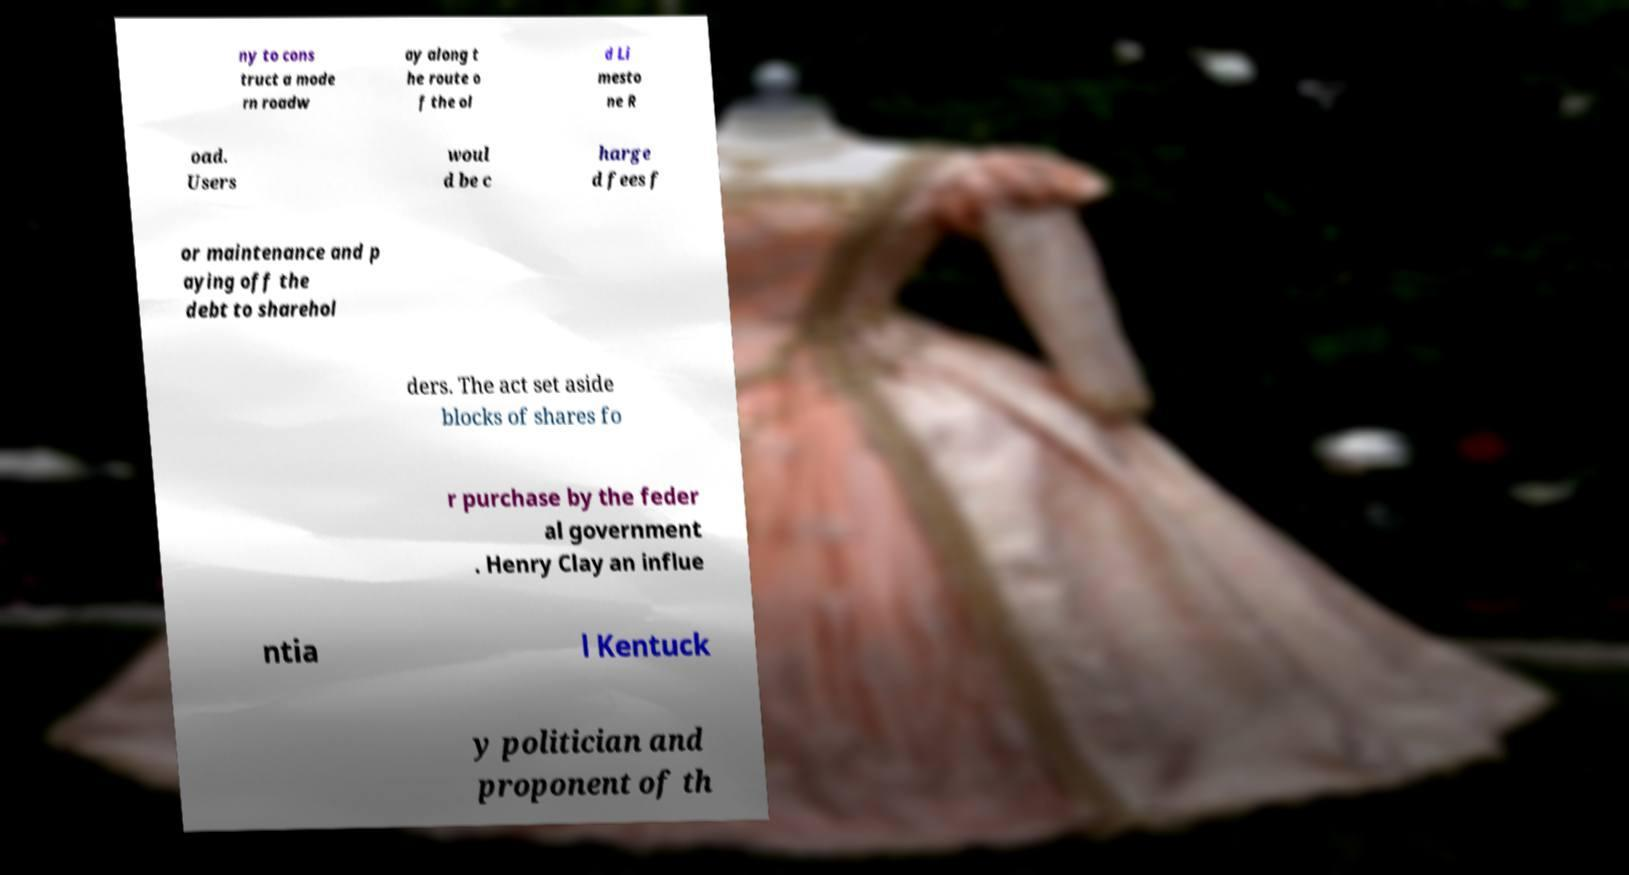Could you extract and type out the text from this image? ny to cons truct a mode rn roadw ay along t he route o f the ol d Li mesto ne R oad. Users woul d be c harge d fees f or maintenance and p aying off the debt to sharehol ders. The act set aside blocks of shares fo r purchase by the feder al government . Henry Clay an influe ntia l Kentuck y politician and proponent of th 